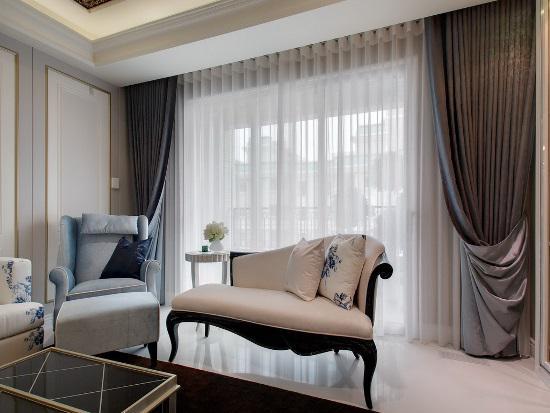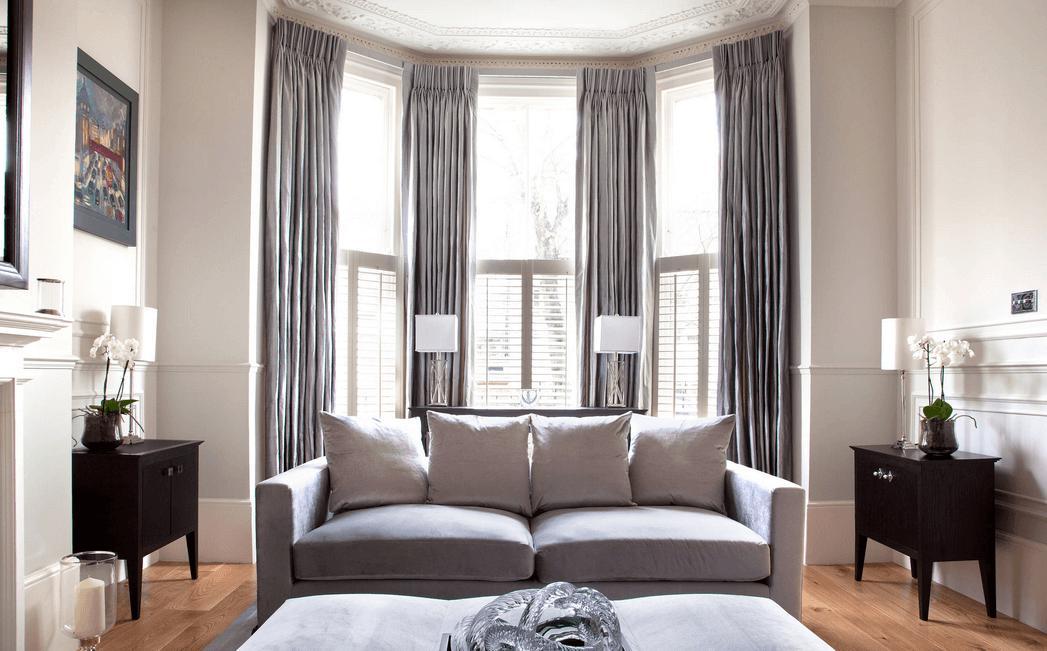The first image is the image on the left, the second image is the image on the right. Considering the images on both sides, is "Sheer white drapes hang from a black horizontal bar in a white room with seating furniture, in one image." valid? Answer yes or no. No. The first image is the image on the left, the second image is the image on the right. Examine the images to the left and right. Is the description "One set of curtains is closed." accurate? Answer yes or no. Yes. 